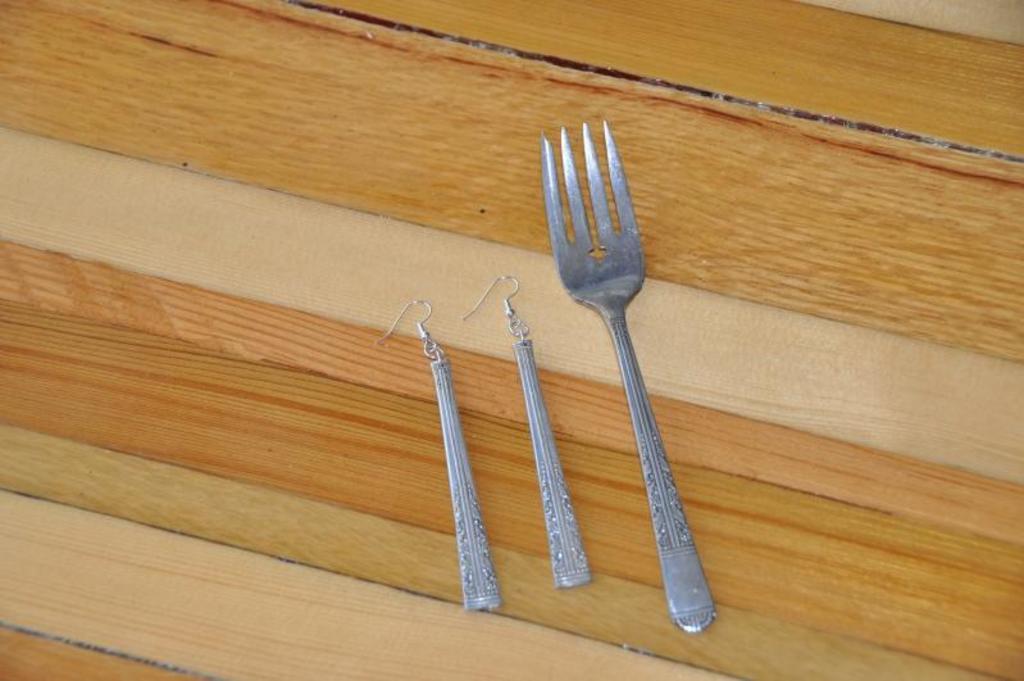Please provide a concise description of this image. In this image, we can see a fork and earrings on the table. 